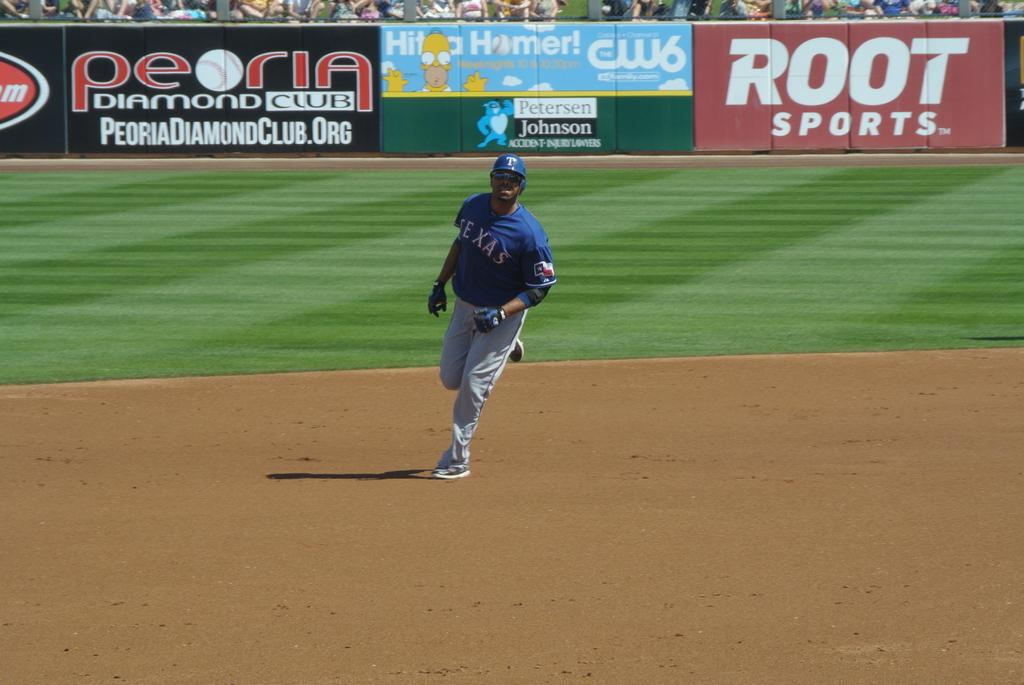Provide a one-sentence caption for the provided image. The Texas baseball player is between second and third base. 